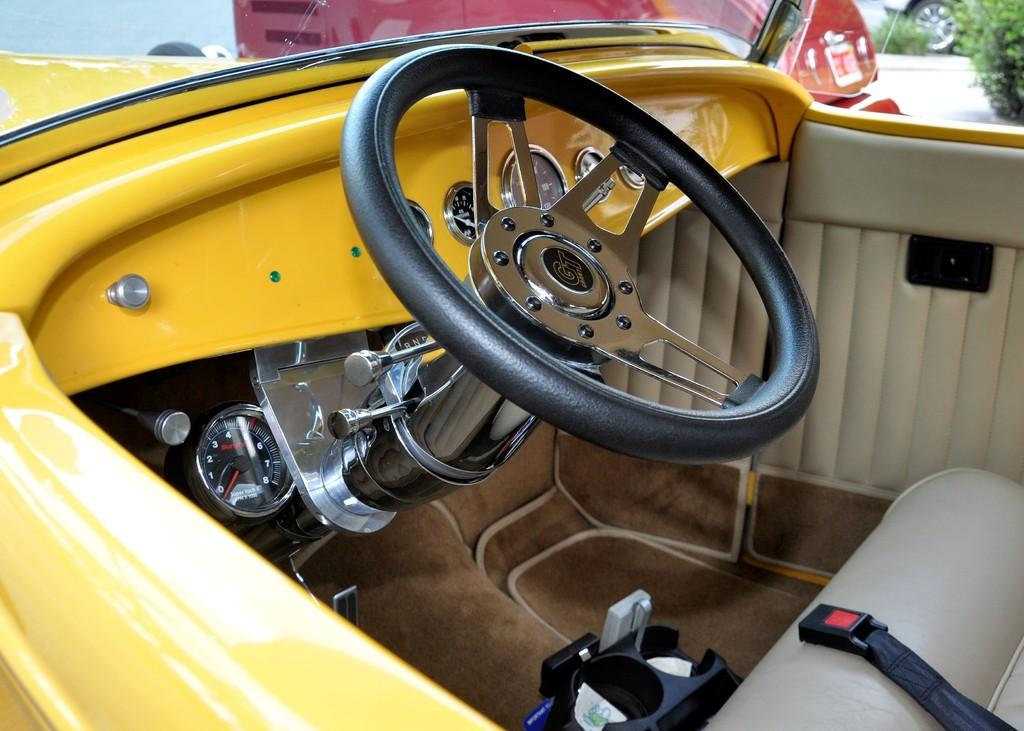What type of setting is depicted in the image? The image shows the inside of a vehicle. What is a prominent feature in the vehicle's interior? There is a steering wheel in the image. What instrument is present for monitoring the vehicle's performance? There is a gauge in the image. What can be seen in the background of the image? The background of the image includes plants and a vehicle wheel. What type of dress is the driver wearing in the image? There is no driver visible in the image, so it is impossible to determine what type of dress they might be wearing. 